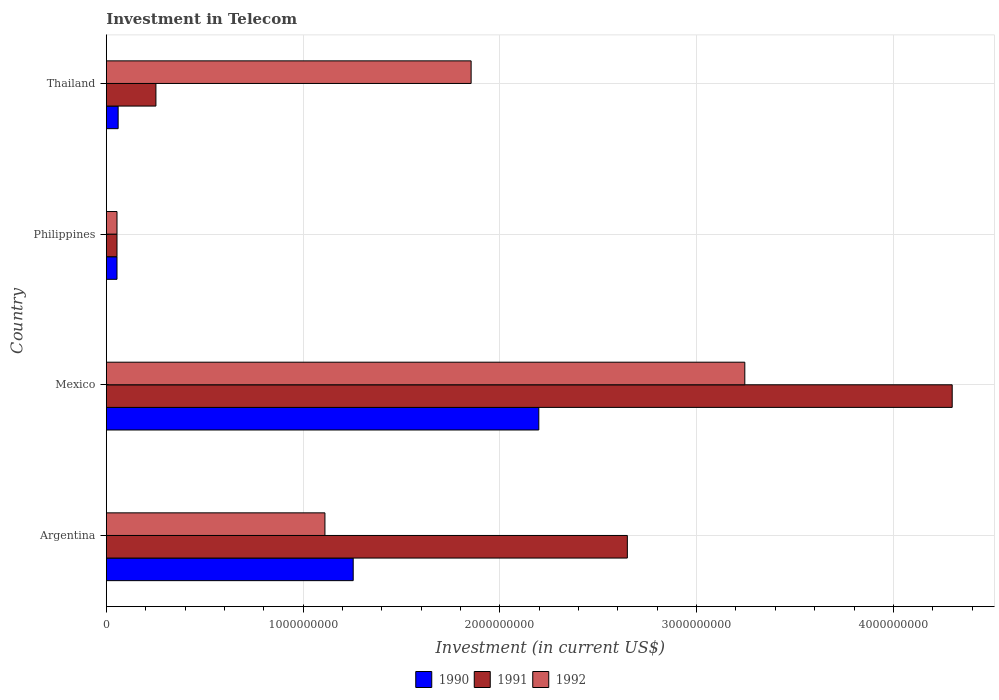How many groups of bars are there?
Your answer should be very brief. 4. How many bars are there on the 2nd tick from the top?
Provide a succinct answer. 3. What is the label of the 1st group of bars from the top?
Keep it short and to the point. Thailand. In how many cases, is the number of bars for a given country not equal to the number of legend labels?
Make the answer very short. 0. What is the amount invested in telecom in 1991 in Thailand?
Your answer should be compact. 2.52e+08. Across all countries, what is the maximum amount invested in telecom in 1991?
Make the answer very short. 4.30e+09. Across all countries, what is the minimum amount invested in telecom in 1991?
Offer a terse response. 5.42e+07. In which country was the amount invested in telecom in 1992 maximum?
Ensure brevity in your answer.  Mexico. What is the total amount invested in telecom in 1991 in the graph?
Ensure brevity in your answer.  7.25e+09. What is the difference between the amount invested in telecom in 1990 in Argentina and that in Philippines?
Make the answer very short. 1.20e+09. What is the difference between the amount invested in telecom in 1991 in Argentina and the amount invested in telecom in 1990 in Philippines?
Offer a terse response. 2.59e+09. What is the average amount invested in telecom in 1990 per country?
Ensure brevity in your answer.  8.92e+08. What is the ratio of the amount invested in telecom in 1992 in Mexico to that in Thailand?
Ensure brevity in your answer.  1.75. Is the difference between the amount invested in telecom in 1992 in Argentina and Mexico greater than the difference between the amount invested in telecom in 1990 in Argentina and Mexico?
Provide a succinct answer. No. What is the difference between the highest and the second highest amount invested in telecom in 1991?
Offer a terse response. 1.65e+09. What is the difference between the highest and the lowest amount invested in telecom in 1991?
Make the answer very short. 4.24e+09. What does the 2nd bar from the top in Thailand represents?
Your answer should be compact. 1991. How many bars are there?
Make the answer very short. 12. What is the difference between two consecutive major ticks on the X-axis?
Offer a very short reply. 1.00e+09. What is the title of the graph?
Provide a succinct answer. Investment in Telecom. What is the label or title of the X-axis?
Your answer should be very brief. Investment (in current US$). What is the label or title of the Y-axis?
Provide a succinct answer. Country. What is the Investment (in current US$) of 1990 in Argentina?
Make the answer very short. 1.25e+09. What is the Investment (in current US$) in 1991 in Argentina?
Provide a short and direct response. 2.65e+09. What is the Investment (in current US$) of 1992 in Argentina?
Provide a succinct answer. 1.11e+09. What is the Investment (in current US$) in 1990 in Mexico?
Make the answer very short. 2.20e+09. What is the Investment (in current US$) of 1991 in Mexico?
Ensure brevity in your answer.  4.30e+09. What is the Investment (in current US$) in 1992 in Mexico?
Ensure brevity in your answer.  3.24e+09. What is the Investment (in current US$) in 1990 in Philippines?
Provide a succinct answer. 5.42e+07. What is the Investment (in current US$) in 1991 in Philippines?
Your answer should be very brief. 5.42e+07. What is the Investment (in current US$) in 1992 in Philippines?
Keep it short and to the point. 5.42e+07. What is the Investment (in current US$) in 1990 in Thailand?
Your answer should be compact. 6.00e+07. What is the Investment (in current US$) of 1991 in Thailand?
Your response must be concise. 2.52e+08. What is the Investment (in current US$) in 1992 in Thailand?
Provide a succinct answer. 1.85e+09. Across all countries, what is the maximum Investment (in current US$) of 1990?
Provide a succinct answer. 2.20e+09. Across all countries, what is the maximum Investment (in current US$) of 1991?
Make the answer very short. 4.30e+09. Across all countries, what is the maximum Investment (in current US$) of 1992?
Provide a short and direct response. 3.24e+09. Across all countries, what is the minimum Investment (in current US$) in 1990?
Provide a short and direct response. 5.42e+07. Across all countries, what is the minimum Investment (in current US$) in 1991?
Provide a succinct answer. 5.42e+07. Across all countries, what is the minimum Investment (in current US$) of 1992?
Your answer should be compact. 5.42e+07. What is the total Investment (in current US$) in 1990 in the graph?
Make the answer very short. 3.57e+09. What is the total Investment (in current US$) in 1991 in the graph?
Offer a terse response. 7.25e+09. What is the total Investment (in current US$) of 1992 in the graph?
Provide a short and direct response. 6.26e+09. What is the difference between the Investment (in current US$) in 1990 in Argentina and that in Mexico?
Your answer should be compact. -9.43e+08. What is the difference between the Investment (in current US$) of 1991 in Argentina and that in Mexico?
Provide a succinct answer. -1.65e+09. What is the difference between the Investment (in current US$) in 1992 in Argentina and that in Mexico?
Offer a terse response. -2.13e+09. What is the difference between the Investment (in current US$) of 1990 in Argentina and that in Philippines?
Your answer should be very brief. 1.20e+09. What is the difference between the Investment (in current US$) of 1991 in Argentina and that in Philippines?
Give a very brief answer. 2.59e+09. What is the difference between the Investment (in current US$) in 1992 in Argentina and that in Philippines?
Your answer should be compact. 1.06e+09. What is the difference between the Investment (in current US$) of 1990 in Argentina and that in Thailand?
Offer a terse response. 1.19e+09. What is the difference between the Investment (in current US$) of 1991 in Argentina and that in Thailand?
Provide a short and direct response. 2.40e+09. What is the difference between the Investment (in current US$) of 1992 in Argentina and that in Thailand?
Keep it short and to the point. -7.43e+08. What is the difference between the Investment (in current US$) of 1990 in Mexico and that in Philippines?
Give a very brief answer. 2.14e+09. What is the difference between the Investment (in current US$) in 1991 in Mexico and that in Philippines?
Keep it short and to the point. 4.24e+09. What is the difference between the Investment (in current US$) in 1992 in Mexico and that in Philippines?
Ensure brevity in your answer.  3.19e+09. What is the difference between the Investment (in current US$) in 1990 in Mexico and that in Thailand?
Give a very brief answer. 2.14e+09. What is the difference between the Investment (in current US$) of 1991 in Mexico and that in Thailand?
Offer a very short reply. 4.05e+09. What is the difference between the Investment (in current US$) in 1992 in Mexico and that in Thailand?
Your answer should be compact. 1.39e+09. What is the difference between the Investment (in current US$) in 1990 in Philippines and that in Thailand?
Offer a terse response. -5.80e+06. What is the difference between the Investment (in current US$) in 1991 in Philippines and that in Thailand?
Ensure brevity in your answer.  -1.98e+08. What is the difference between the Investment (in current US$) of 1992 in Philippines and that in Thailand?
Ensure brevity in your answer.  -1.80e+09. What is the difference between the Investment (in current US$) of 1990 in Argentina and the Investment (in current US$) of 1991 in Mexico?
Offer a very short reply. -3.04e+09. What is the difference between the Investment (in current US$) in 1990 in Argentina and the Investment (in current US$) in 1992 in Mexico?
Provide a succinct answer. -1.99e+09. What is the difference between the Investment (in current US$) of 1991 in Argentina and the Investment (in current US$) of 1992 in Mexico?
Your answer should be compact. -5.97e+08. What is the difference between the Investment (in current US$) in 1990 in Argentina and the Investment (in current US$) in 1991 in Philippines?
Offer a terse response. 1.20e+09. What is the difference between the Investment (in current US$) in 1990 in Argentina and the Investment (in current US$) in 1992 in Philippines?
Ensure brevity in your answer.  1.20e+09. What is the difference between the Investment (in current US$) in 1991 in Argentina and the Investment (in current US$) in 1992 in Philippines?
Your answer should be very brief. 2.59e+09. What is the difference between the Investment (in current US$) in 1990 in Argentina and the Investment (in current US$) in 1991 in Thailand?
Provide a short and direct response. 1.00e+09. What is the difference between the Investment (in current US$) of 1990 in Argentina and the Investment (in current US$) of 1992 in Thailand?
Give a very brief answer. -5.99e+08. What is the difference between the Investment (in current US$) of 1991 in Argentina and the Investment (in current US$) of 1992 in Thailand?
Keep it short and to the point. 7.94e+08. What is the difference between the Investment (in current US$) in 1990 in Mexico and the Investment (in current US$) in 1991 in Philippines?
Provide a short and direct response. 2.14e+09. What is the difference between the Investment (in current US$) of 1990 in Mexico and the Investment (in current US$) of 1992 in Philippines?
Ensure brevity in your answer.  2.14e+09. What is the difference between the Investment (in current US$) in 1991 in Mexico and the Investment (in current US$) in 1992 in Philippines?
Make the answer very short. 4.24e+09. What is the difference between the Investment (in current US$) of 1990 in Mexico and the Investment (in current US$) of 1991 in Thailand?
Your response must be concise. 1.95e+09. What is the difference between the Investment (in current US$) of 1990 in Mexico and the Investment (in current US$) of 1992 in Thailand?
Make the answer very short. 3.44e+08. What is the difference between the Investment (in current US$) of 1991 in Mexico and the Investment (in current US$) of 1992 in Thailand?
Offer a very short reply. 2.44e+09. What is the difference between the Investment (in current US$) of 1990 in Philippines and the Investment (in current US$) of 1991 in Thailand?
Your answer should be very brief. -1.98e+08. What is the difference between the Investment (in current US$) in 1990 in Philippines and the Investment (in current US$) in 1992 in Thailand?
Provide a succinct answer. -1.80e+09. What is the difference between the Investment (in current US$) of 1991 in Philippines and the Investment (in current US$) of 1992 in Thailand?
Keep it short and to the point. -1.80e+09. What is the average Investment (in current US$) in 1990 per country?
Ensure brevity in your answer.  8.92e+08. What is the average Investment (in current US$) in 1991 per country?
Your answer should be compact. 1.81e+09. What is the average Investment (in current US$) of 1992 per country?
Your response must be concise. 1.57e+09. What is the difference between the Investment (in current US$) in 1990 and Investment (in current US$) in 1991 in Argentina?
Provide a short and direct response. -1.39e+09. What is the difference between the Investment (in current US$) in 1990 and Investment (in current US$) in 1992 in Argentina?
Your response must be concise. 1.44e+08. What is the difference between the Investment (in current US$) in 1991 and Investment (in current US$) in 1992 in Argentina?
Keep it short and to the point. 1.54e+09. What is the difference between the Investment (in current US$) in 1990 and Investment (in current US$) in 1991 in Mexico?
Your response must be concise. -2.10e+09. What is the difference between the Investment (in current US$) of 1990 and Investment (in current US$) of 1992 in Mexico?
Provide a succinct answer. -1.05e+09. What is the difference between the Investment (in current US$) in 1991 and Investment (in current US$) in 1992 in Mexico?
Provide a short and direct response. 1.05e+09. What is the difference between the Investment (in current US$) of 1990 and Investment (in current US$) of 1991 in Philippines?
Your answer should be compact. 0. What is the difference between the Investment (in current US$) in 1990 and Investment (in current US$) in 1992 in Philippines?
Offer a terse response. 0. What is the difference between the Investment (in current US$) in 1991 and Investment (in current US$) in 1992 in Philippines?
Make the answer very short. 0. What is the difference between the Investment (in current US$) in 1990 and Investment (in current US$) in 1991 in Thailand?
Your answer should be compact. -1.92e+08. What is the difference between the Investment (in current US$) in 1990 and Investment (in current US$) in 1992 in Thailand?
Provide a succinct answer. -1.79e+09. What is the difference between the Investment (in current US$) of 1991 and Investment (in current US$) of 1992 in Thailand?
Your answer should be compact. -1.60e+09. What is the ratio of the Investment (in current US$) of 1990 in Argentina to that in Mexico?
Keep it short and to the point. 0.57. What is the ratio of the Investment (in current US$) in 1991 in Argentina to that in Mexico?
Give a very brief answer. 0.62. What is the ratio of the Investment (in current US$) in 1992 in Argentina to that in Mexico?
Give a very brief answer. 0.34. What is the ratio of the Investment (in current US$) of 1990 in Argentina to that in Philippines?
Offer a terse response. 23.15. What is the ratio of the Investment (in current US$) in 1991 in Argentina to that in Philippines?
Give a very brief answer. 48.86. What is the ratio of the Investment (in current US$) of 1992 in Argentina to that in Philippines?
Offer a very short reply. 20.5. What is the ratio of the Investment (in current US$) of 1990 in Argentina to that in Thailand?
Offer a terse response. 20.91. What is the ratio of the Investment (in current US$) of 1991 in Argentina to that in Thailand?
Your answer should be very brief. 10.51. What is the ratio of the Investment (in current US$) of 1992 in Argentina to that in Thailand?
Ensure brevity in your answer.  0.6. What is the ratio of the Investment (in current US$) of 1990 in Mexico to that in Philippines?
Ensure brevity in your answer.  40.55. What is the ratio of the Investment (in current US$) of 1991 in Mexico to that in Philippines?
Provide a succinct answer. 79.32. What is the ratio of the Investment (in current US$) in 1992 in Mexico to that in Philippines?
Make the answer very short. 59.87. What is the ratio of the Investment (in current US$) in 1990 in Mexico to that in Thailand?
Provide a succinct answer. 36.63. What is the ratio of the Investment (in current US$) of 1991 in Mexico to that in Thailand?
Provide a succinct answer. 17.06. What is the ratio of the Investment (in current US$) in 1992 in Mexico to that in Thailand?
Make the answer very short. 1.75. What is the ratio of the Investment (in current US$) in 1990 in Philippines to that in Thailand?
Your response must be concise. 0.9. What is the ratio of the Investment (in current US$) in 1991 in Philippines to that in Thailand?
Offer a very short reply. 0.22. What is the ratio of the Investment (in current US$) in 1992 in Philippines to that in Thailand?
Keep it short and to the point. 0.03. What is the difference between the highest and the second highest Investment (in current US$) of 1990?
Keep it short and to the point. 9.43e+08. What is the difference between the highest and the second highest Investment (in current US$) in 1991?
Your answer should be compact. 1.65e+09. What is the difference between the highest and the second highest Investment (in current US$) in 1992?
Offer a very short reply. 1.39e+09. What is the difference between the highest and the lowest Investment (in current US$) in 1990?
Keep it short and to the point. 2.14e+09. What is the difference between the highest and the lowest Investment (in current US$) of 1991?
Ensure brevity in your answer.  4.24e+09. What is the difference between the highest and the lowest Investment (in current US$) in 1992?
Offer a terse response. 3.19e+09. 